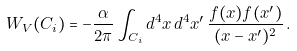Convert formula to latex. <formula><loc_0><loc_0><loc_500><loc_500>W _ { V } ( C _ { i } ) = - \frac { \alpha } { 2 \pi } \int _ { C _ { i } } { d ^ { 4 } } x \, { d ^ { 4 } } x ^ { \prime } \, \frac { f ( x ) f ( x ^ { \prime } ) } { ( x - x ^ { \prime } ) ^ { 2 } } \, .</formula> 